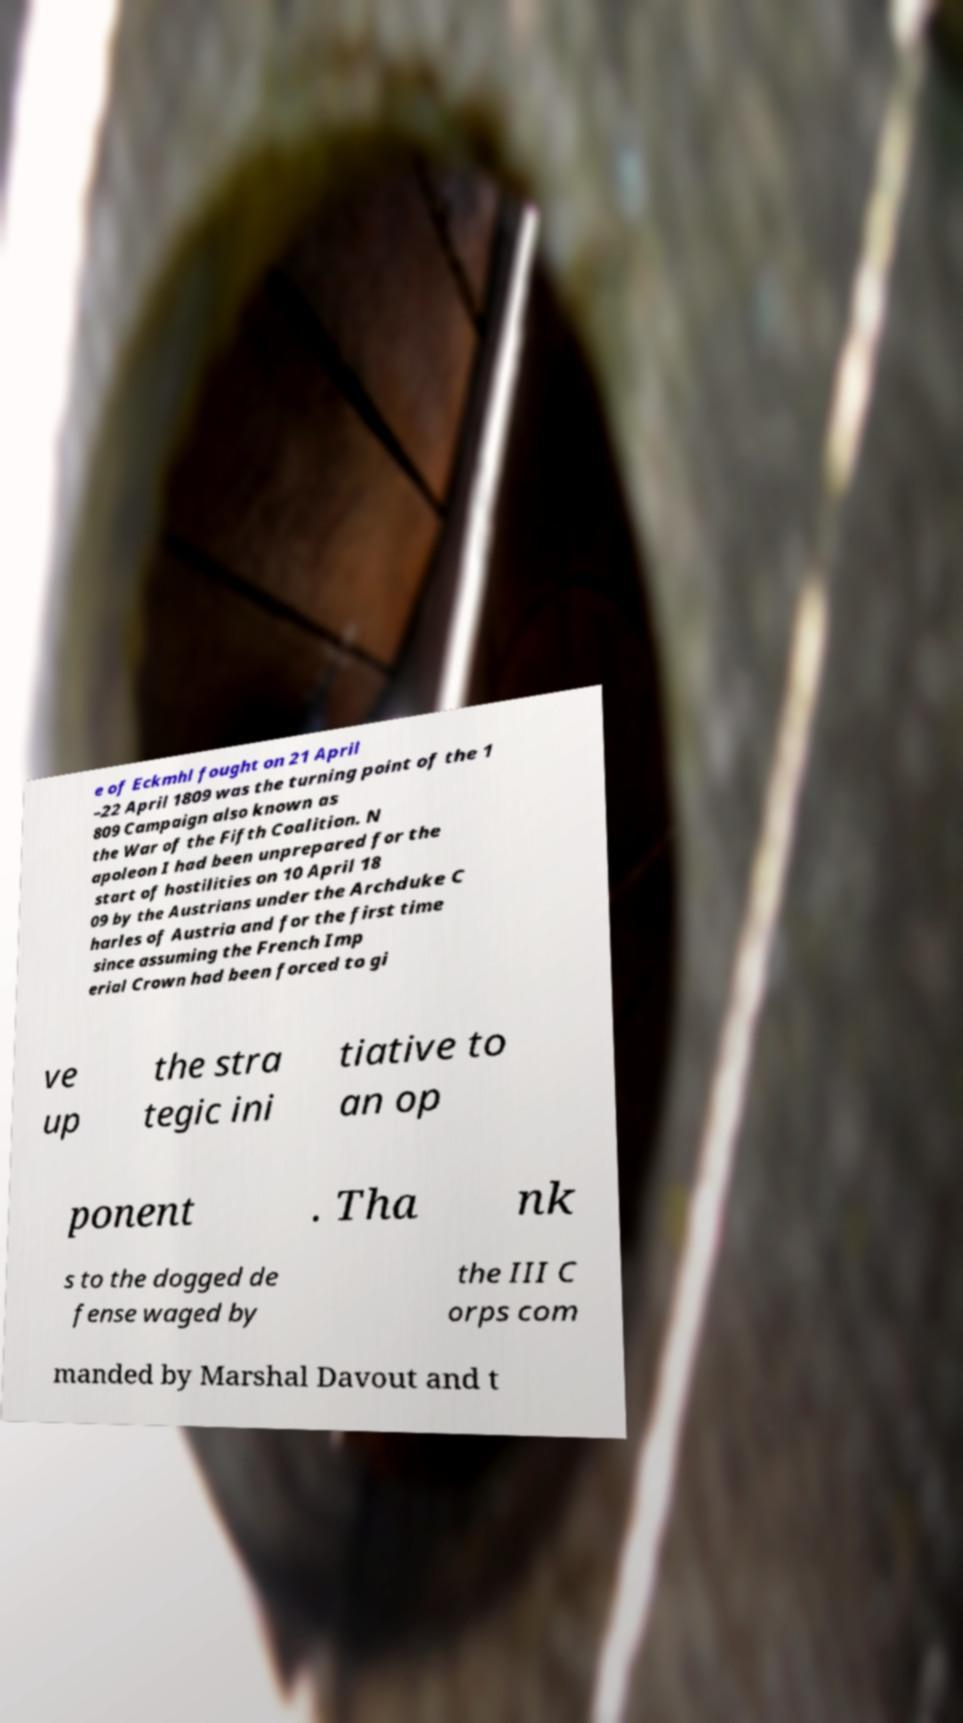For documentation purposes, I need the text within this image transcribed. Could you provide that? e of Eckmhl fought on 21 April –22 April 1809 was the turning point of the 1 809 Campaign also known as the War of the Fifth Coalition. N apoleon I had been unprepared for the start of hostilities on 10 April 18 09 by the Austrians under the Archduke C harles of Austria and for the first time since assuming the French Imp erial Crown had been forced to gi ve up the stra tegic ini tiative to an op ponent . Tha nk s to the dogged de fense waged by the III C orps com manded by Marshal Davout and t 